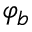<formula> <loc_0><loc_0><loc_500><loc_500>\varphi _ { b }</formula> 